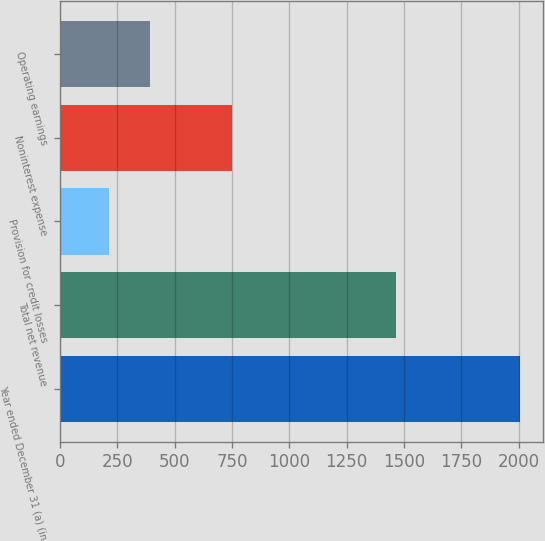Convert chart. <chart><loc_0><loc_0><loc_500><loc_500><bar_chart><fcel>Year ended December 31 (a) (in<fcel>Total net revenue<fcel>Provision for credit losses<fcel>Noninterest expense<fcel>Operating earnings<nl><fcel>2005<fcel>1467<fcel>212<fcel>751<fcel>391.3<nl></chart> 